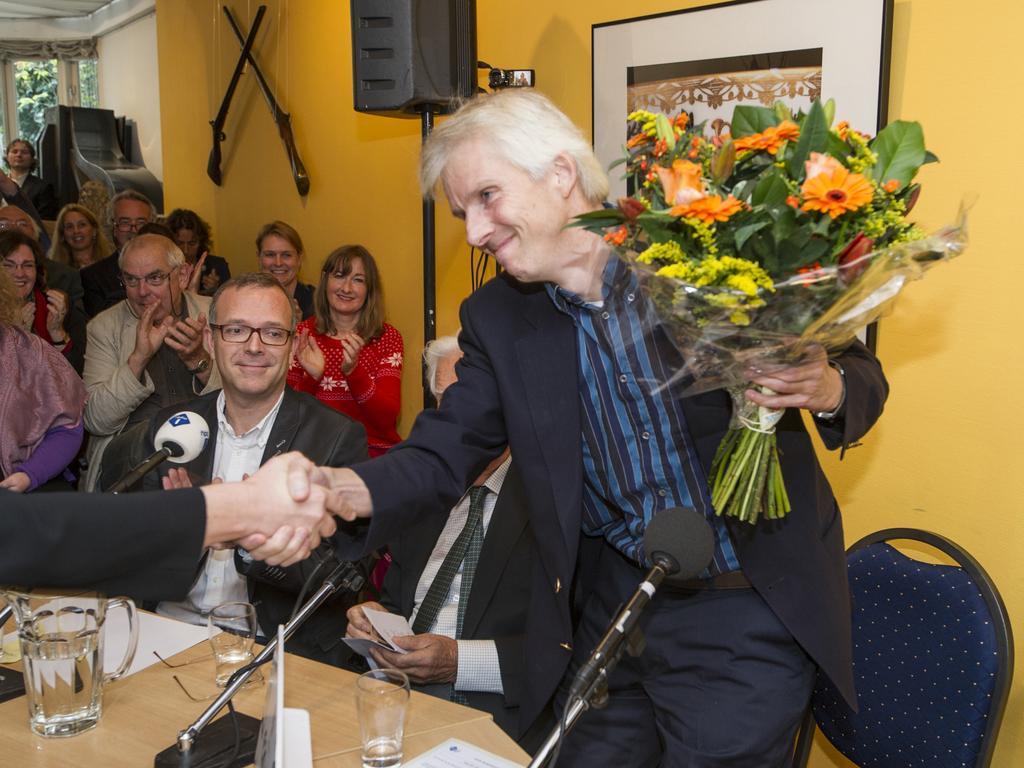Please provide a concise description of this image. In this picture we can see a man is standing and holding a bouquet and other people are sitting on chairs. In front of the man there is a table and on the table there are glasses, papers and a microphone. Behind the man there is a chair, speaker to the stand and a wall with a photo frame. 